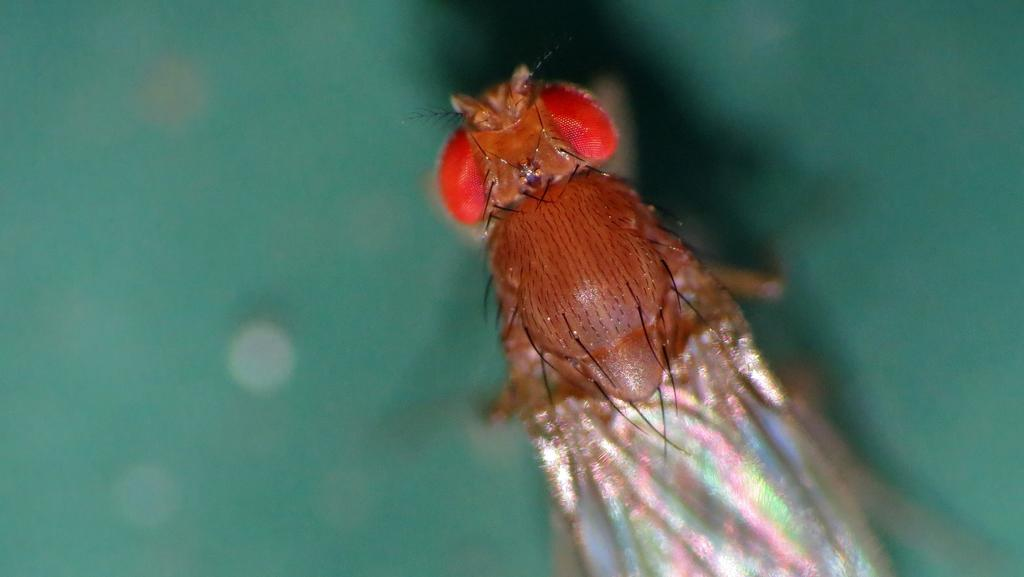What type of creature can be seen in the image? There is an insect in the image. How does the insect tie a knot in the image? Insects do not have the ability to tie knots, and there is no knot present in the image. 